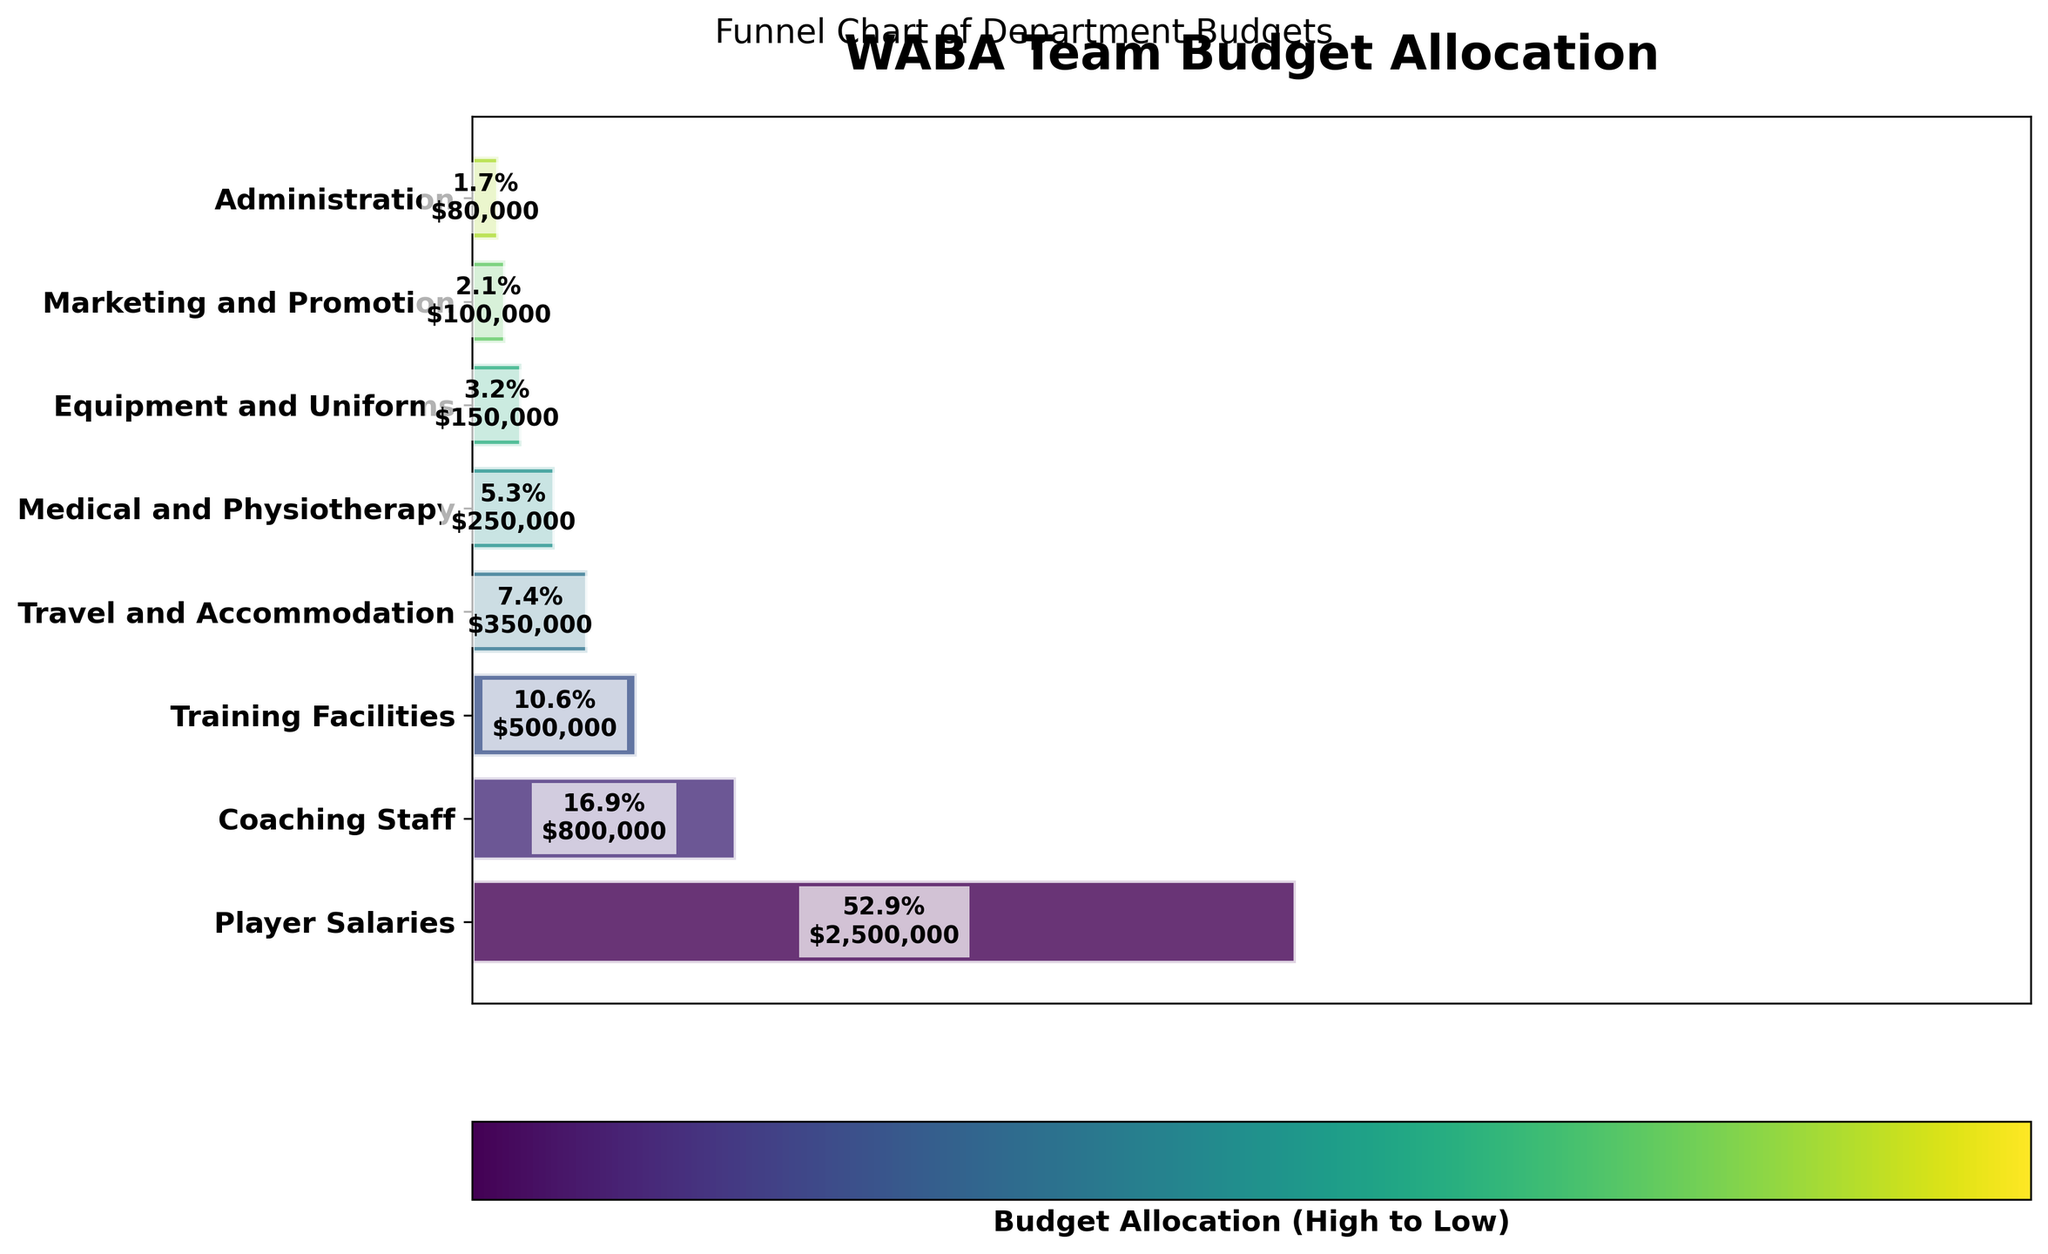Which department has the highest budget allocation? The figure shows that the 'Player Salaries' department has the widest bar, indicating the highest budget allocation.
Answer: Player Salaries What percentage of the budget is allocated to Coaching Staff? The figure displays the percentage within the bar for 'Coaching Staff,' which is 16%.
Answer: 16% How much is the total budget sum from Medical and Physiotherapy, and Equipment and Uniforms? The figure shows the budget allocations for 'Medical and Physiotherapy' ($250,000) and 'Equipment and Uniforms' ($150,000). Summing them gives $250,000 + $150,000 = $400,000.
Answer: $400,000 Which department's budget allocation is exactly $100,000? The figure shows the exact budget allocation of $100,000 in one of the bars, which corresponds to the 'Marketing and Promotion' department.
Answer: Marketing and Promotion How does the budget for Training Facilities compare to Travel and Accommodation? The figure shows that 'Training Facilities' has a budget allocation of $500,000 whereas 'Travel and Accommodation' has $350,000. As a result, Training Facilities has a higher budget.
Answer: Training Facilities What is the total percentage for Administration and Marketing and Promotion combined? The figure shows 'Administration' with 0.9% and 'Marketing and Promotion' with 2%. Summing them gives 0.9% + 2% = 2.9%.
Answer: 2.9% Which department has the lowest budget allocation, and what is its value in dollars? The figure indicates the smallest bar corresponds to 'Administration,' which has a budget allocation of $80,000.
Answer: Administration, $80,000 How many departments have their budgets explicitly listed in the figure? The figure shows the budget allocations for eight departments.
Answer: 8 What is the combined budget allocation for the top three departments? The figure shows the top three departments as 'Player Salaries,' 'Coaching Staff,' and 'Training Facilities' with budget allocations of $2,500,000, $800,000, and $500,000 respectively. Summing them gives $2,500,000 + $800,000 + $500,000 = $3,800,000.
Answer: $3,800,000 